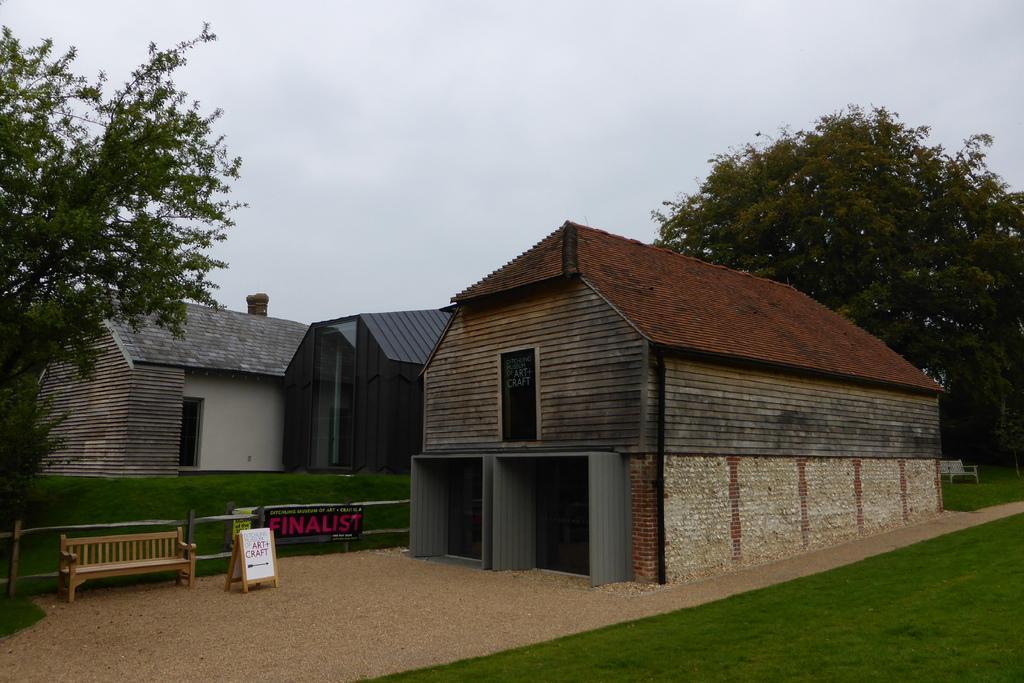Please provide a concise description of this image. In the center of the image there is sand. There is a benches. There is a board. There is a metal fence. there is a banner. There are houses. On both right and left side of the image there is grass on the surface. There are trees. In the background of the image there is sky. 